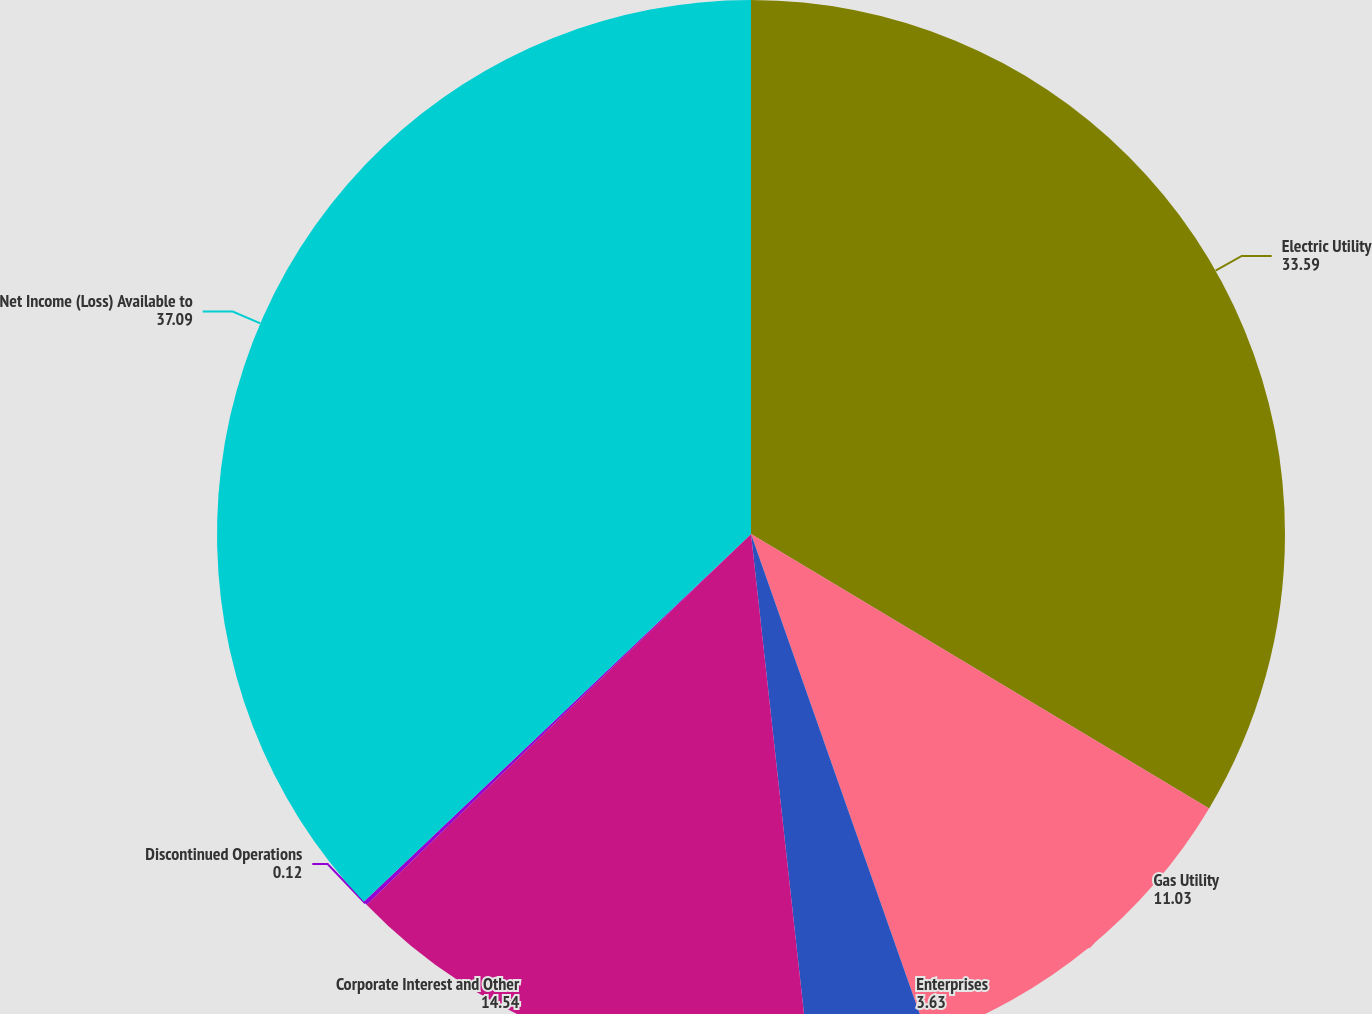Convert chart. <chart><loc_0><loc_0><loc_500><loc_500><pie_chart><fcel>Electric Utility<fcel>Gas Utility<fcel>Enterprises<fcel>Corporate Interest and Other<fcel>Discontinued Operations<fcel>Net Income (Loss) Available to<nl><fcel>33.59%<fcel>11.03%<fcel>3.63%<fcel>14.54%<fcel>0.12%<fcel>37.09%<nl></chart> 